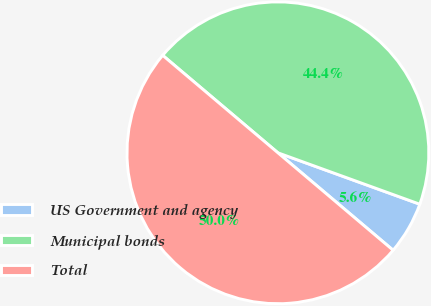Convert chart. <chart><loc_0><loc_0><loc_500><loc_500><pie_chart><fcel>US Government and agency<fcel>Municipal bonds<fcel>Total<nl><fcel>5.64%<fcel>44.36%<fcel>50.0%<nl></chart> 